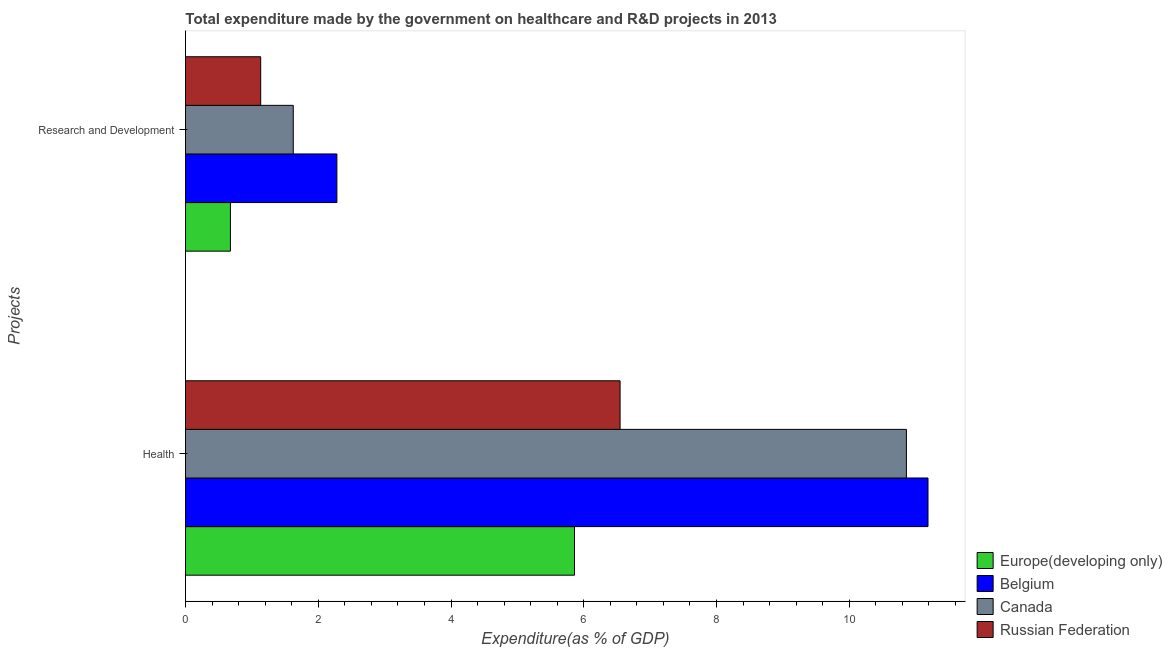How many bars are there on the 2nd tick from the bottom?
Give a very brief answer. 4. What is the label of the 1st group of bars from the top?
Provide a short and direct response. Research and Development. What is the expenditure in r&d in Russian Federation?
Make the answer very short. 1.13. Across all countries, what is the maximum expenditure in healthcare?
Your answer should be very brief. 11.19. Across all countries, what is the minimum expenditure in healthcare?
Keep it short and to the point. 5.86. In which country was the expenditure in healthcare maximum?
Provide a short and direct response. Belgium. In which country was the expenditure in healthcare minimum?
Ensure brevity in your answer.  Europe(developing only). What is the total expenditure in r&d in the graph?
Ensure brevity in your answer.  5.71. What is the difference between the expenditure in r&d in Russian Federation and that in Canada?
Your answer should be compact. -0.49. What is the difference between the expenditure in r&d in Russian Federation and the expenditure in healthcare in Belgium?
Make the answer very short. -10.05. What is the average expenditure in r&d per country?
Provide a short and direct response. 1.43. What is the difference between the expenditure in healthcare and expenditure in r&d in Europe(developing only)?
Your answer should be compact. 5.18. What is the ratio of the expenditure in healthcare in Canada to that in Europe(developing only)?
Offer a very short reply. 1.85. What does the 1st bar from the top in Research and Development represents?
Provide a short and direct response. Russian Federation. What does the 3rd bar from the bottom in Research and Development represents?
Offer a very short reply. Canada. Are the values on the major ticks of X-axis written in scientific E-notation?
Offer a very short reply. No. Does the graph contain grids?
Your response must be concise. No. How many legend labels are there?
Give a very brief answer. 4. How are the legend labels stacked?
Provide a succinct answer. Vertical. What is the title of the graph?
Offer a very short reply. Total expenditure made by the government on healthcare and R&D projects in 2013. Does "Canada" appear as one of the legend labels in the graph?
Keep it short and to the point. Yes. What is the label or title of the X-axis?
Your response must be concise. Expenditure(as % of GDP). What is the label or title of the Y-axis?
Offer a very short reply. Projects. What is the Expenditure(as % of GDP) of Europe(developing only) in Health?
Provide a succinct answer. 5.86. What is the Expenditure(as % of GDP) in Belgium in Health?
Your answer should be very brief. 11.19. What is the Expenditure(as % of GDP) in Canada in Health?
Your response must be concise. 10.86. What is the Expenditure(as % of GDP) in Russian Federation in Health?
Provide a succinct answer. 6.55. What is the Expenditure(as % of GDP) in Europe(developing only) in Research and Development?
Keep it short and to the point. 0.68. What is the Expenditure(as % of GDP) of Belgium in Research and Development?
Offer a very short reply. 2.28. What is the Expenditure(as % of GDP) in Canada in Research and Development?
Offer a very short reply. 1.62. What is the Expenditure(as % of GDP) of Russian Federation in Research and Development?
Provide a succinct answer. 1.13. Across all Projects, what is the maximum Expenditure(as % of GDP) in Europe(developing only)?
Keep it short and to the point. 5.86. Across all Projects, what is the maximum Expenditure(as % of GDP) of Belgium?
Provide a short and direct response. 11.19. Across all Projects, what is the maximum Expenditure(as % of GDP) in Canada?
Provide a short and direct response. 10.86. Across all Projects, what is the maximum Expenditure(as % of GDP) in Russian Federation?
Make the answer very short. 6.55. Across all Projects, what is the minimum Expenditure(as % of GDP) of Europe(developing only)?
Provide a succinct answer. 0.68. Across all Projects, what is the minimum Expenditure(as % of GDP) of Belgium?
Make the answer very short. 2.28. Across all Projects, what is the minimum Expenditure(as % of GDP) of Canada?
Make the answer very short. 1.62. Across all Projects, what is the minimum Expenditure(as % of GDP) of Russian Federation?
Offer a terse response. 1.13. What is the total Expenditure(as % of GDP) in Europe(developing only) in the graph?
Provide a succinct answer. 6.54. What is the total Expenditure(as % of GDP) of Belgium in the graph?
Your response must be concise. 13.47. What is the total Expenditure(as % of GDP) of Canada in the graph?
Your answer should be very brief. 12.48. What is the total Expenditure(as % of GDP) of Russian Federation in the graph?
Offer a very short reply. 7.68. What is the difference between the Expenditure(as % of GDP) in Europe(developing only) in Health and that in Research and Development?
Make the answer very short. 5.18. What is the difference between the Expenditure(as % of GDP) in Belgium in Health and that in Research and Development?
Provide a succinct answer. 8.91. What is the difference between the Expenditure(as % of GDP) in Canada in Health and that in Research and Development?
Your response must be concise. 9.24. What is the difference between the Expenditure(as % of GDP) of Russian Federation in Health and that in Research and Development?
Provide a short and direct response. 5.41. What is the difference between the Expenditure(as % of GDP) of Europe(developing only) in Health and the Expenditure(as % of GDP) of Belgium in Research and Development?
Offer a terse response. 3.58. What is the difference between the Expenditure(as % of GDP) of Europe(developing only) in Health and the Expenditure(as % of GDP) of Canada in Research and Development?
Your answer should be very brief. 4.24. What is the difference between the Expenditure(as % of GDP) in Europe(developing only) in Health and the Expenditure(as % of GDP) in Russian Federation in Research and Development?
Give a very brief answer. 4.73. What is the difference between the Expenditure(as % of GDP) in Belgium in Health and the Expenditure(as % of GDP) in Canada in Research and Development?
Your answer should be compact. 9.56. What is the difference between the Expenditure(as % of GDP) in Belgium in Health and the Expenditure(as % of GDP) in Russian Federation in Research and Development?
Provide a succinct answer. 10.05. What is the difference between the Expenditure(as % of GDP) of Canada in Health and the Expenditure(as % of GDP) of Russian Federation in Research and Development?
Provide a succinct answer. 9.73. What is the average Expenditure(as % of GDP) of Europe(developing only) per Projects?
Your answer should be very brief. 3.27. What is the average Expenditure(as % of GDP) of Belgium per Projects?
Keep it short and to the point. 6.73. What is the average Expenditure(as % of GDP) in Canada per Projects?
Provide a short and direct response. 6.24. What is the average Expenditure(as % of GDP) in Russian Federation per Projects?
Provide a short and direct response. 3.84. What is the difference between the Expenditure(as % of GDP) of Europe(developing only) and Expenditure(as % of GDP) of Belgium in Health?
Give a very brief answer. -5.33. What is the difference between the Expenditure(as % of GDP) in Europe(developing only) and Expenditure(as % of GDP) in Canada in Health?
Give a very brief answer. -5. What is the difference between the Expenditure(as % of GDP) of Europe(developing only) and Expenditure(as % of GDP) of Russian Federation in Health?
Offer a terse response. -0.69. What is the difference between the Expenditure(as % of GDP) of Belgium and Expenditure(as % of GDP) of Canada in Health?
Keep it short and to the point. 0.33. What is the difference between the Expenditure(as % of GDP) of Belgium and Expenditure(as % of GDP) of Russian Federation in Health?
Offer a very short reply. 4.64. What is the difference between the Expenditure(as % of GDP) of Canada and Expenditure(as % of GDP) of Russian Federation in Health?
Your answer should be compact. 4.31. What is the difference between the Expenditure(as % of GDP) of Europe(developing only) and Expenditure(as % of GDP) of Belgium in Research and Development?
Provide a succinct answer. -1.6. What is the difference between the Expenditure(as % of GDP) of Europe(developing only) and Expenditure(as % of GDP) of Canada in Research and Development?
Offer a very short reply. -0.95. What is the difference between the Expenditure(as % of GDP) in Europe(developing only) and Expenditure(as % of GDP) in Russian Federation in Research and Development?
Ensure brevity in your answer.  -0.46. What is the difference between the Expenditure(as % of GDP) of Belgium and Expenditure(as % of GDP) of Canada in Research and Development?
Provide a short and direct response. 0.66. What is the difference between the Expenditure(as % of GDP) of Belgium and Expenditure(as % of GDP) of Russian Federation in Research and Development?
Ensure brevity in your answer.  1.15. What is the difference between the Expenditure(as % of GDP) of Canada and Expenditure(as % of GDP) of Russian Federation in Research and Development?
Ensure brevity in your answer.  0.49. What is the ratio of the Expenditure(as % of GDP) of Europe(developing only) in Health to that in Research and Development?
Make the answer very short. 8.66. What is the ratio of the Expenditure(as % of GDP) in Belgium in Health to that in Research and Development?
Offer a very short reply. 4.9. What is the ratio of the Expenditure(as % of GDP) in Canada in Health to that in Research and Development?
Offer a very short reply. 6.69. What is the ratio of the Expenditure(as % of GDP) in Russian Federation in Health to that in Research and Development?
Give a very brief answer. 5.78. What is the difference between the highest and the second highest Expenditure(as % of GDP) in Europe(developing only)?
Ensure brevity in your answer.  5.18. What is the difference between the highest and the second highest Expenditure(as % of GDP) of Belgium?
Make the answer very short. 8.91. What is the difference between the highest and the second highest Expenditure(as % of GDP) in Canada?
Make the answer very short. 9.24. What is the difference between the highest and the second highest Expenditure(as % of GDP) of Russian Federation?
Ensure brevity in your answer.  5.41. What is the difference between the highest and the lowest Expenditure(as % of GDP) in Europe(developing only)?
Provide a short and direct response. 5.18. What is the difference between the highest and the lowest Expenditure(as % of GDP) in Belgium?
Your answer should be very brief. 8.91. What is the difference between the highest and the lowest Expenditure(as % of GDP) in Canada?
Your response must be concise. 9.24. What is the difference between the highest and the lowest Expenditure(as % of GDP) of Russian Federation?
Keep it short and to the point. 5.41. 